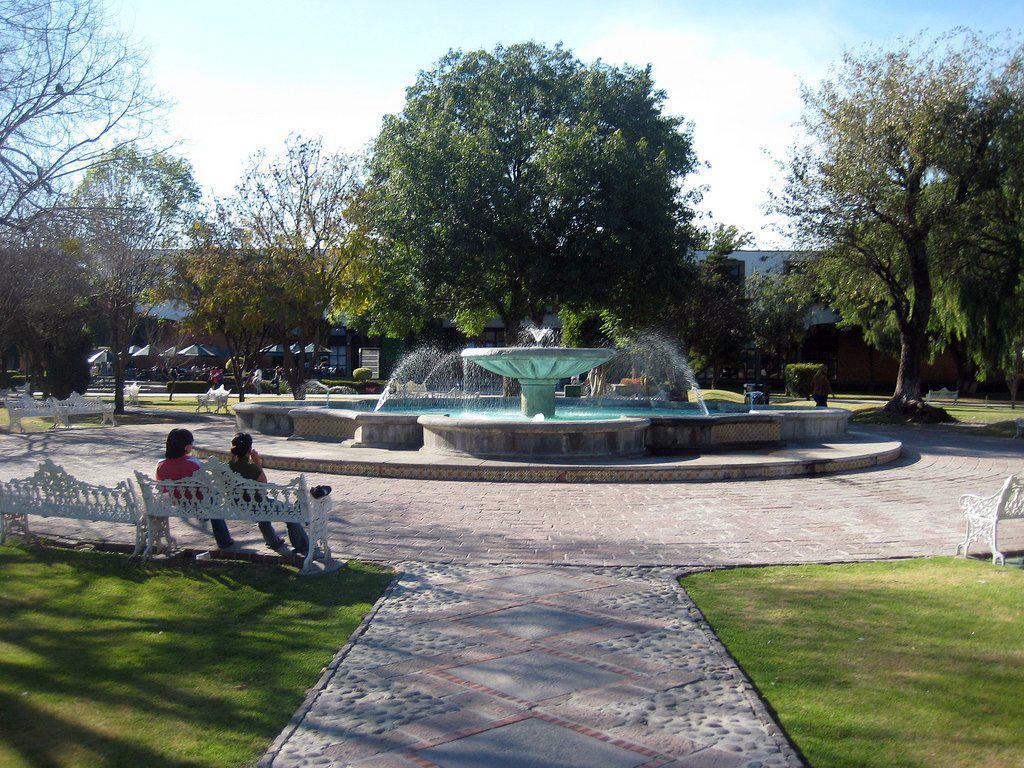How would you summarize this image in a sentence or two? This picture is clicked outside. In the foreground we can see the green grass, benches and the two persons sitting on the bench. In the center we can see the fountain and a water body. In the background we can see the sky, trees, buildings, umbrellas, plants and many other objects. 